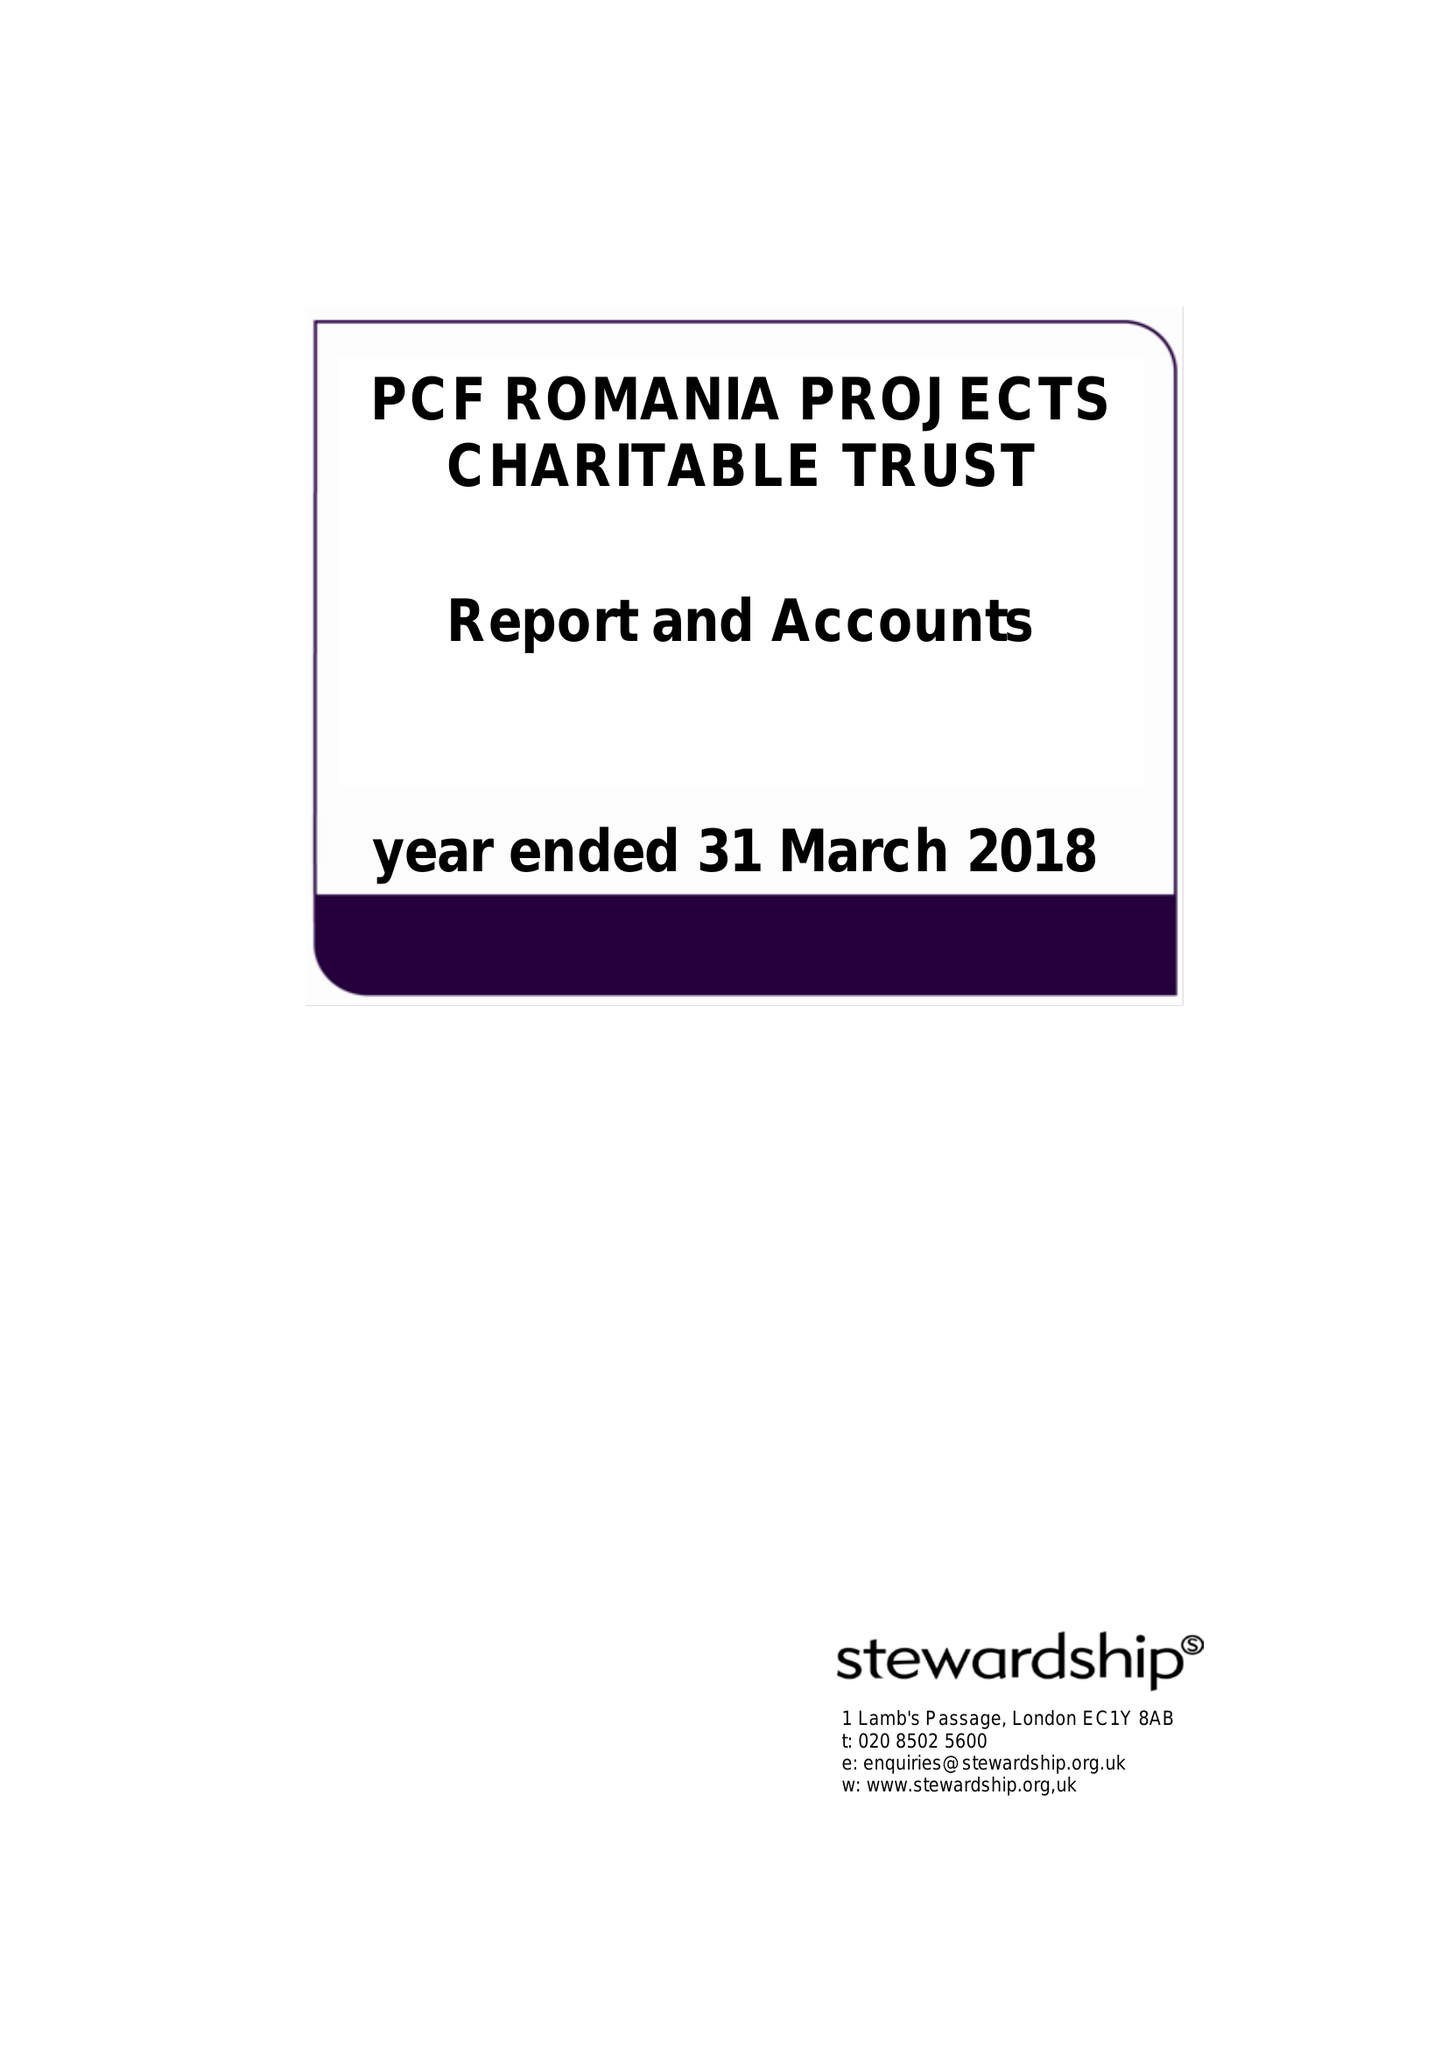What is the value for the address__street_line?
Answer the question using a single word or phrase. 2 THORNBURY COURT 